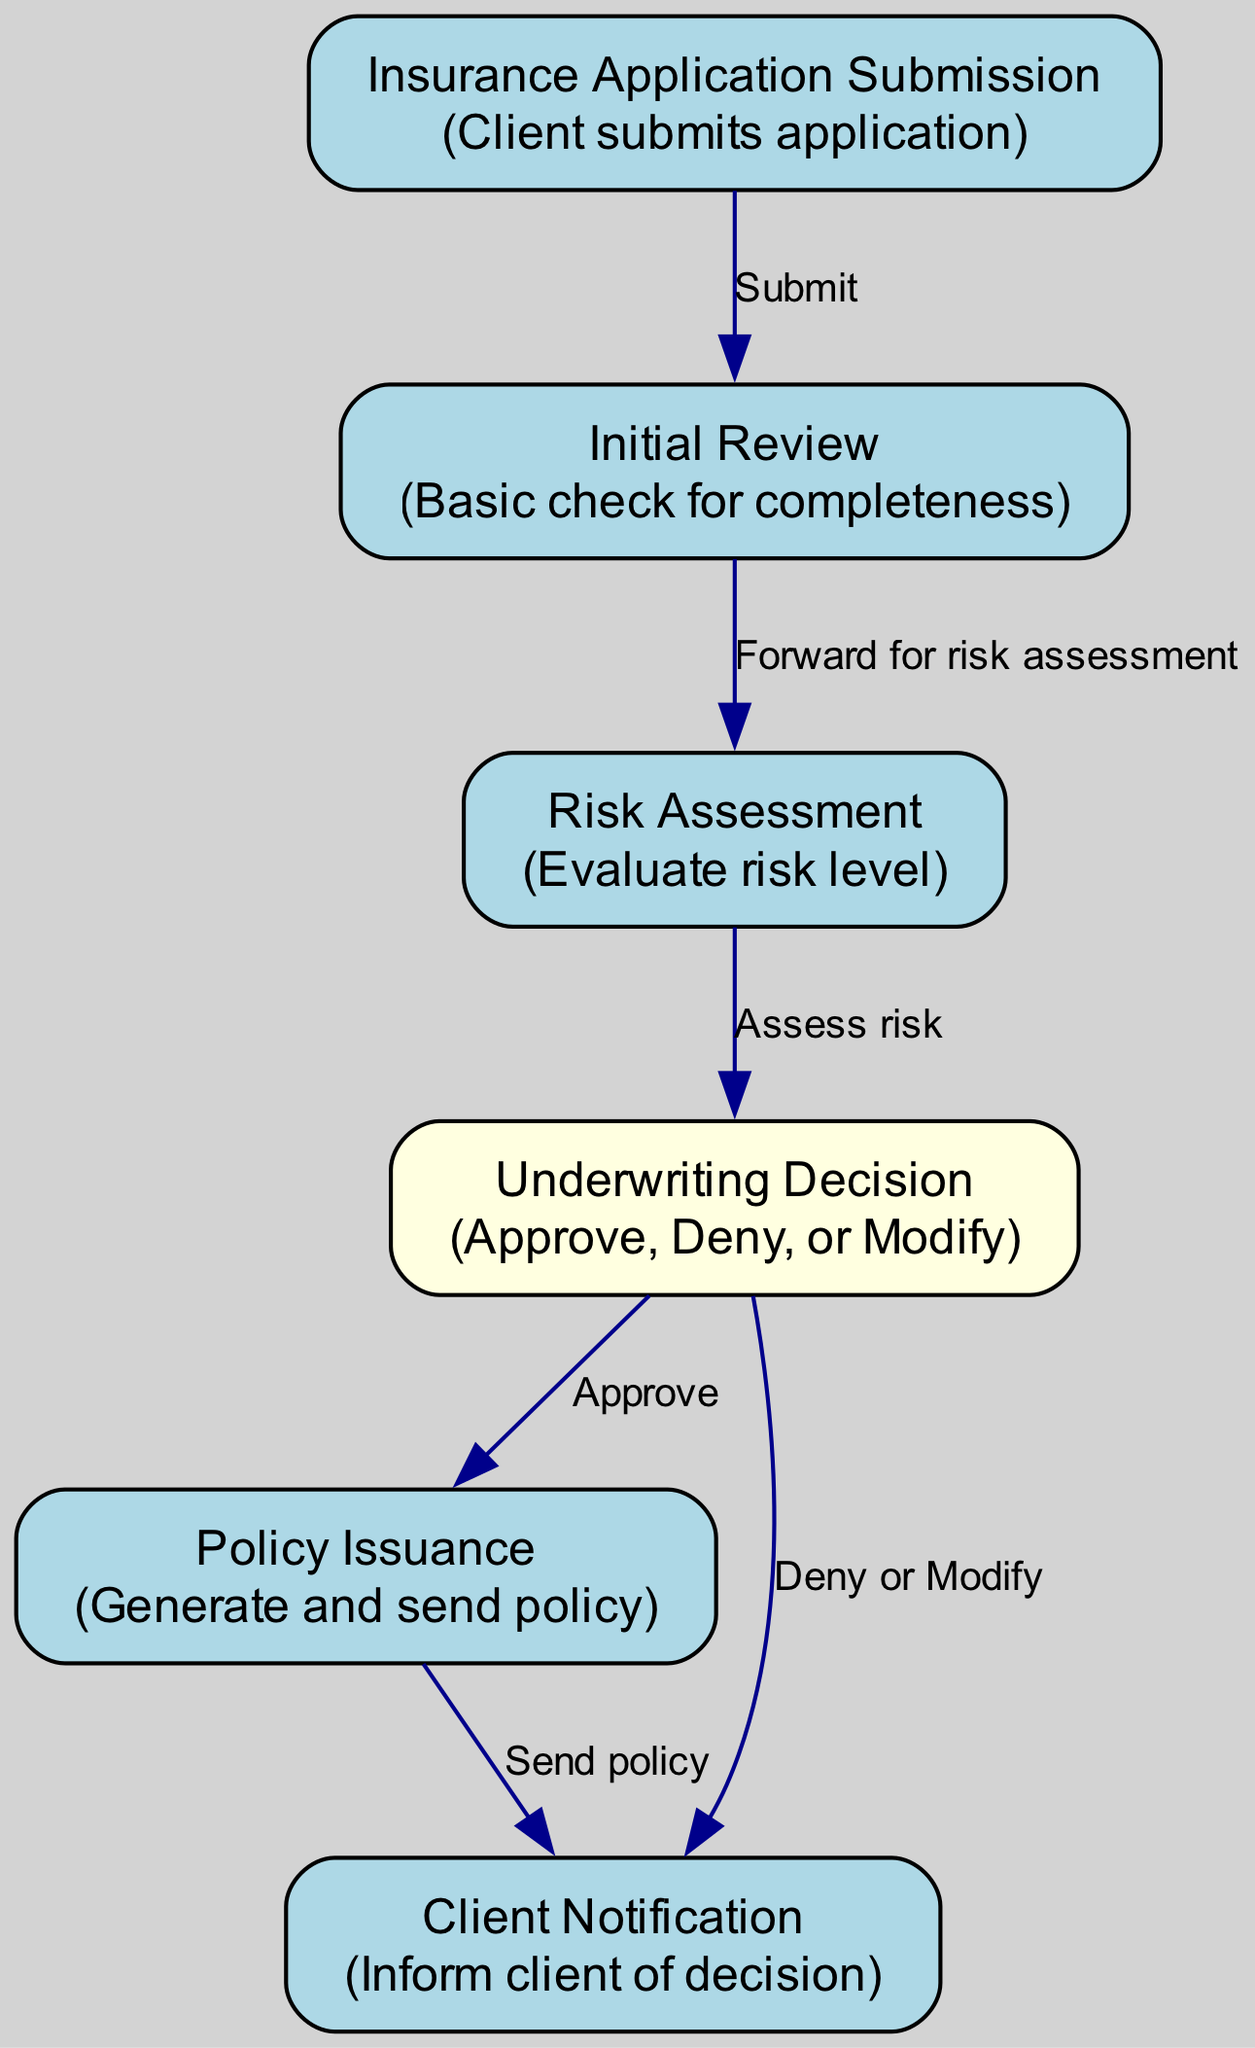What is the first step in the process? The first step is represented by the node labeled "Insurance Application Submission," indicating that the process begins when a client submits their application.
Answer: Insurance Application Submission How many nodes are there in the diagram? The diagram consists of six nodes, each representing a distinct part of the insurance application process.
Answer: 6 What happens if the underwriting decision is to deny or modify the application? This leads to the "Client Notification" node, which informs the client of the decision. This relationship is shown by an edge from the "Underwriting Decision" node to the "Client Notification" node labeled "Deny or Modify."
Answer: Client Notification What is the label of the edge from the Initial Review to Risk Assessment? The edge from "Initial Review" to "Risk Assessment" is labeled "Forward for risk assessment," indicating the action taken after the initial review.
Answer: Forward for risk assessment What color is the 'Underwriting Decision' node? The 'Underwriting Decision' node is colored light yellow, distinguishing it from other nodes that are light blue.
Answer: Light yellow What is the final action taken in the process? The final action described in the diagram is "Policy Issuance," which occurs after the underwriting decision is approved.
Answer: Policy Issuance What are the three possible outcomes after Risk Assessment? The three outcomes from the "Risk Assessment" node can be "Approve," "Deny," or "Modify," as indicated by the connections leading to the "Underwriting Decision" node.
Answer: Approve, Deny, or Modify How does a client know the decision made regarding their application? The client is informed via the "Client Notification" node, which is reached following the underwriting decision made after risk assessment.
Answer: Client Notification What type of relationship is illustrated between the 'Policy Issuance' and 'Client Notification' nodes? The relationship illustrates a sequential action where the policy is sent to the client after it is issued, as shown by the edge labeled "Send policy."
Answer: Send policy 